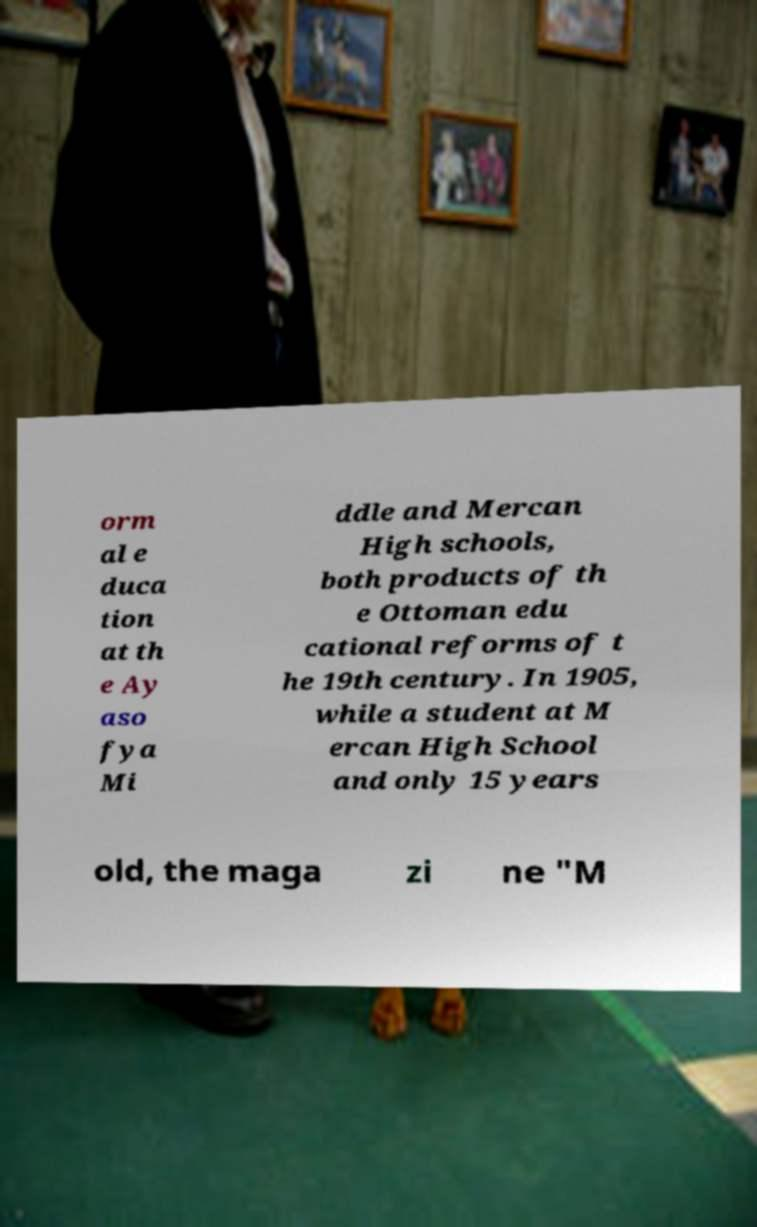Can you read and provide the text displayed in the image?This photo seems to have some interesting text. Can you extract and type it out for me? orm al e duca tion at th e Ay aso fya Mi ddle and Mercan High schools, both products of th e Ottoman edu cational reforms of t he 19th century. In 1905, while a student at M ercan High School and only 15 years old, the maga zi ne "M 